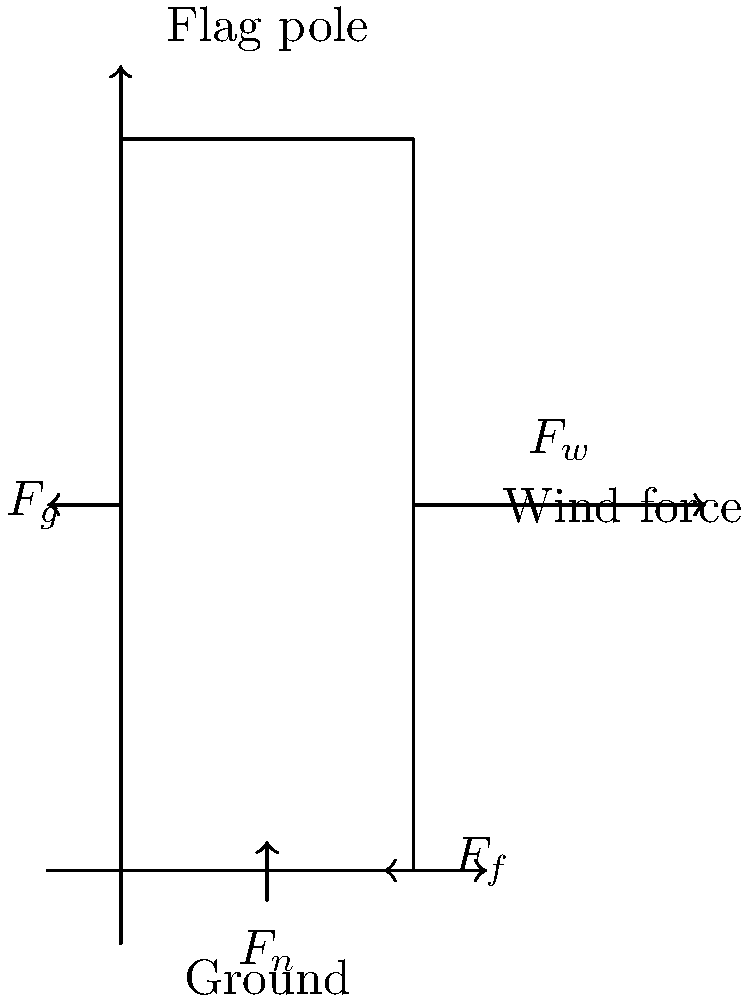As a proud American, you're concerned about the stability of flag poles during strong winds. Consider a flag pole subjected to high wind speeds. What are the primary forces acting on the pole, and how do they contribute to its stability or potential for failure? Let's break this down step-by-step:

1. Wind Force ($F_w$): 
   - This is the primary horizontal force acting on the flag pole.
   - It increases with wind speed and the surface area of the pole and flag.
   - Direction: Parallel to the ground, in the direction of the wind.

2. Gravitational Force ($F_g$):
   - This is the weight of the flag pole and flag.
   - Direction: Vertically downward.
   - Contributes to stability by keeping the pole grounded.

3. Normal Force ($F_n$):
   - Exerted by the ground on the base of the pole.
   - Direction: Perpendicular to the ground, upward.
   - Balances the gravitational force under static conditions.

4. Friction Force ($F_f$):
   - Acts at the base of the pole, opposing the wind force.
   - Direction: Horizontal, opposite to the wind force.
   - Helps prevent the pole from sliding.

5. Moment of Force:
   - The wind force creates a turning effect (moment) about the base of the pole.
   - This is countered by the moment created by the pole's weight and any additional support structures.

Stability depends on:
a) The magnitude of the wind force vs. the pole's weight and support.
b) The height of the pole (longer lever arm increases the turning moment).
c) The strength of the pole material to resist bending.
d) The effectiveness of the foundation in resisting overturning.

Potential for failure occurs when:
- The wind force creates a moment that exceeds the countering moments.
- The bending stress in the pole material exceeds its yield strength.
- The foundation fails to provide adequate support against overturning or sliding.
Answer: Wind force, gravity, normal force, and friction; stability depends on balancing these forces and moments. 